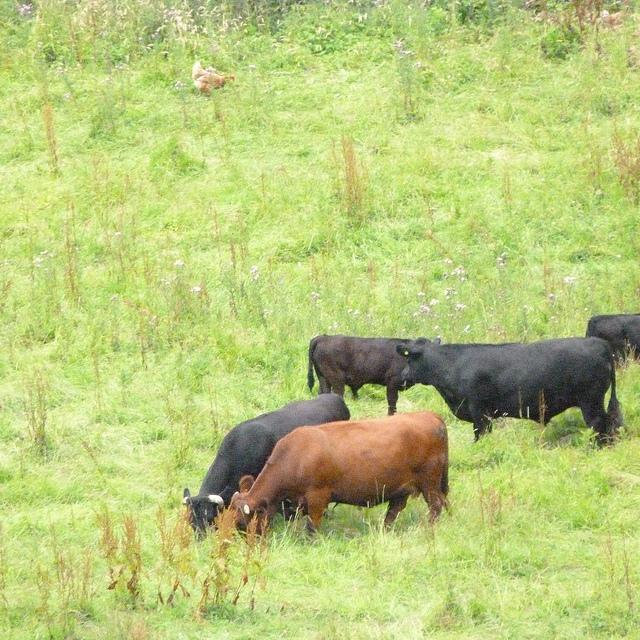How many cows are in the photo?
Give a very brief answer. 4. 